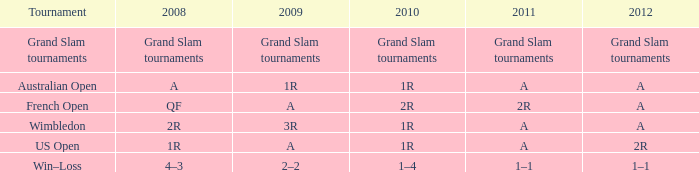Identify the 2r tournament that took place in 2011. French Open. 